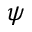<formula> <loc_0><loc_0><loc_500><loc_500>\psi</formula> 